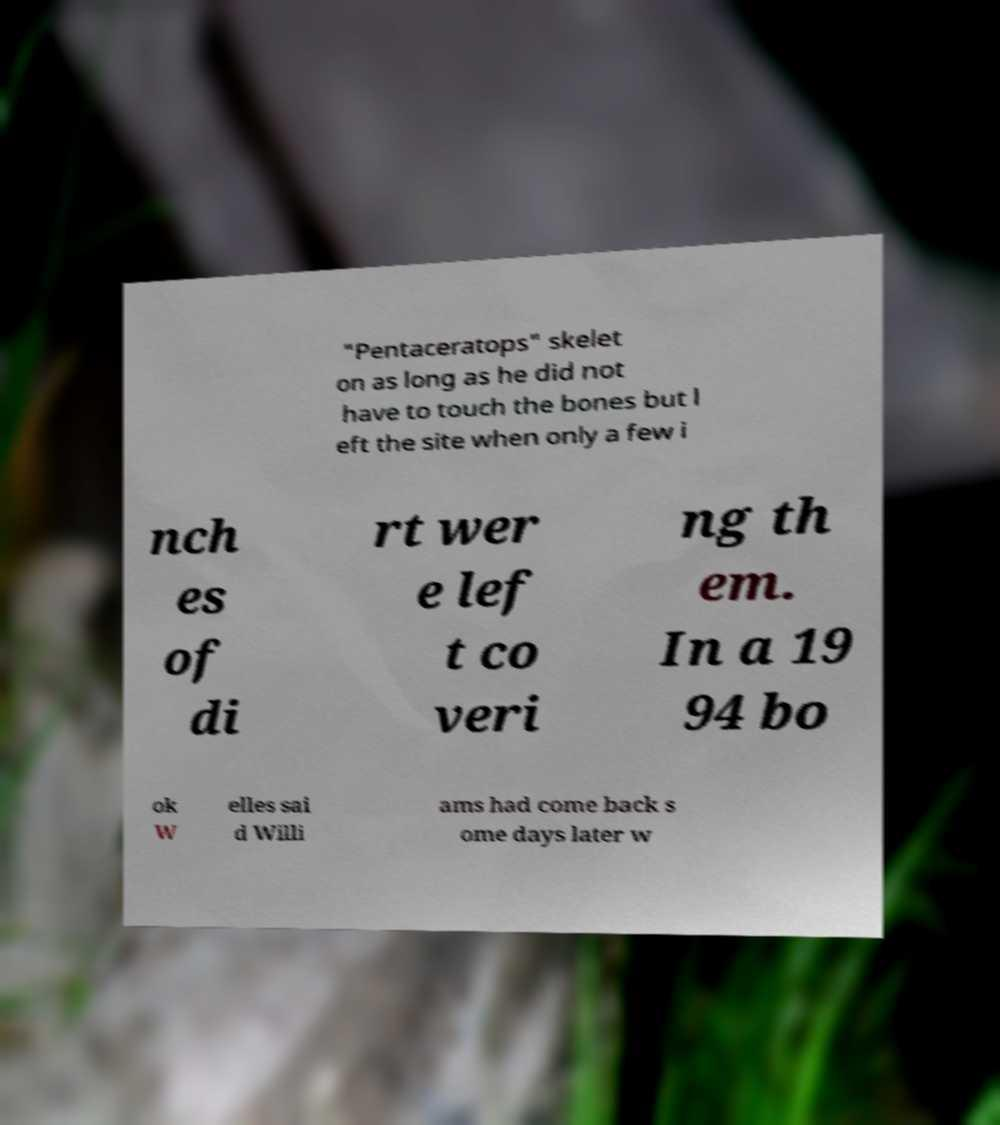Can you accurately transcribe the text from the provided image for me? "Pentaceratops" skelet on as long as he did not have to touch the bones but l eft the site when only a few i nch es of di rt wer e lef t co veri ng th em. In a 19 94 bo ok W elles sai d Willi ams had come back s ome days later w 